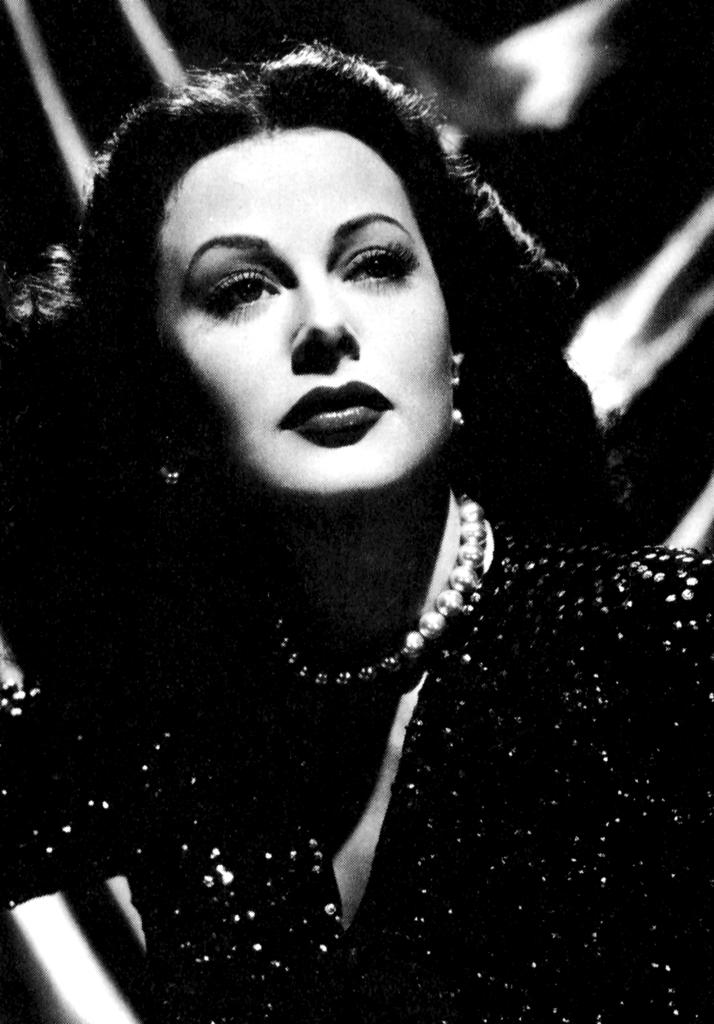What type of image is present in the picture? There is an old photograph in the image. Who is featured in the old photograph? The photograph features a woman. What is the woman wearing in the old photograph? The woman is wearing a black dress and a beads necklace. How is the beads necklace positioned on the woman? The necklace is around her neck. What can be observed about the background of the old photograph? The background of the old photograph is blurred. What type of regret can be seen on the woman's face in the image? There is no indication of regret on the woman's face in the image; it is an old photograph, and her facial expression cannot be determined. 